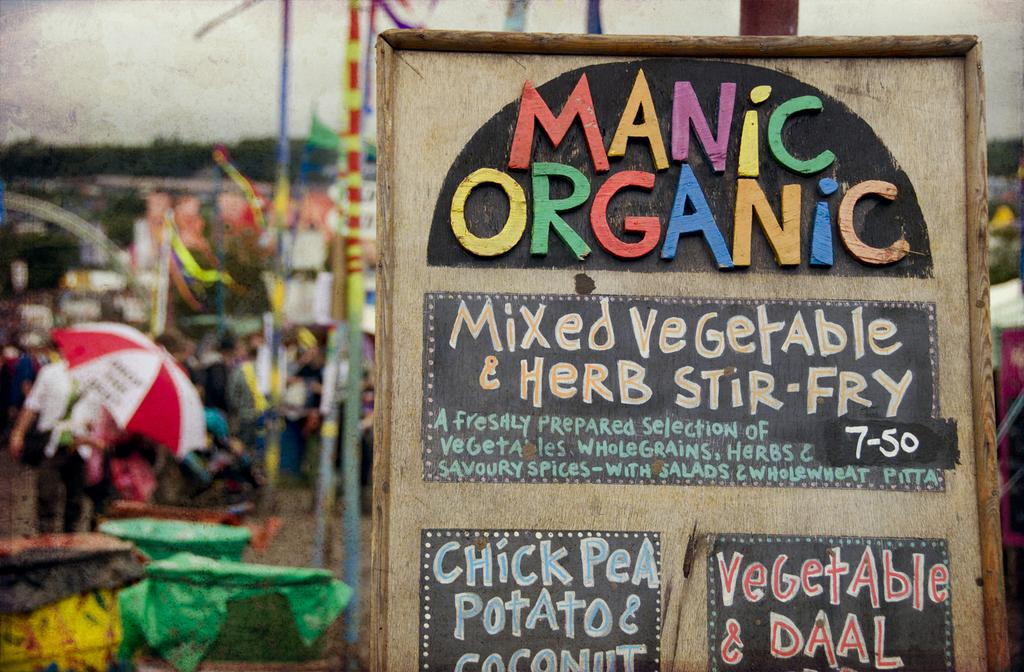Who is holding an object in the image? There is a person holding a camera in the image. What can be seen in the background of the image? There is a building in the background of the image. What part of the natural environment is visible in the image? The sky is visible in the image. What type of frog can be seen on the board in the image? There is no board mentioned in the transcript or the facts. Additionally, there is no mention of a frog in the transcript or the facts. 